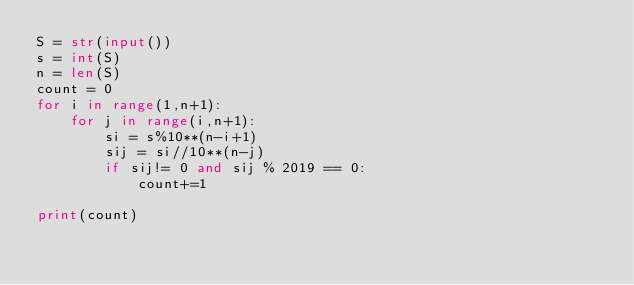<code> <loc_0><loc_0><loc_500><loc_500><_Python_>S = str(input())
s = int(S)
n = len(S)
count = 0
for i in range(1,n+1):
    for j in range(i,n+1):
        si = s%10**(n-i+1)
        sij = si//10**(n-j)
        if sij!= 0 and sij % 2019 == 0:
            count+=1

print(count)</code> 